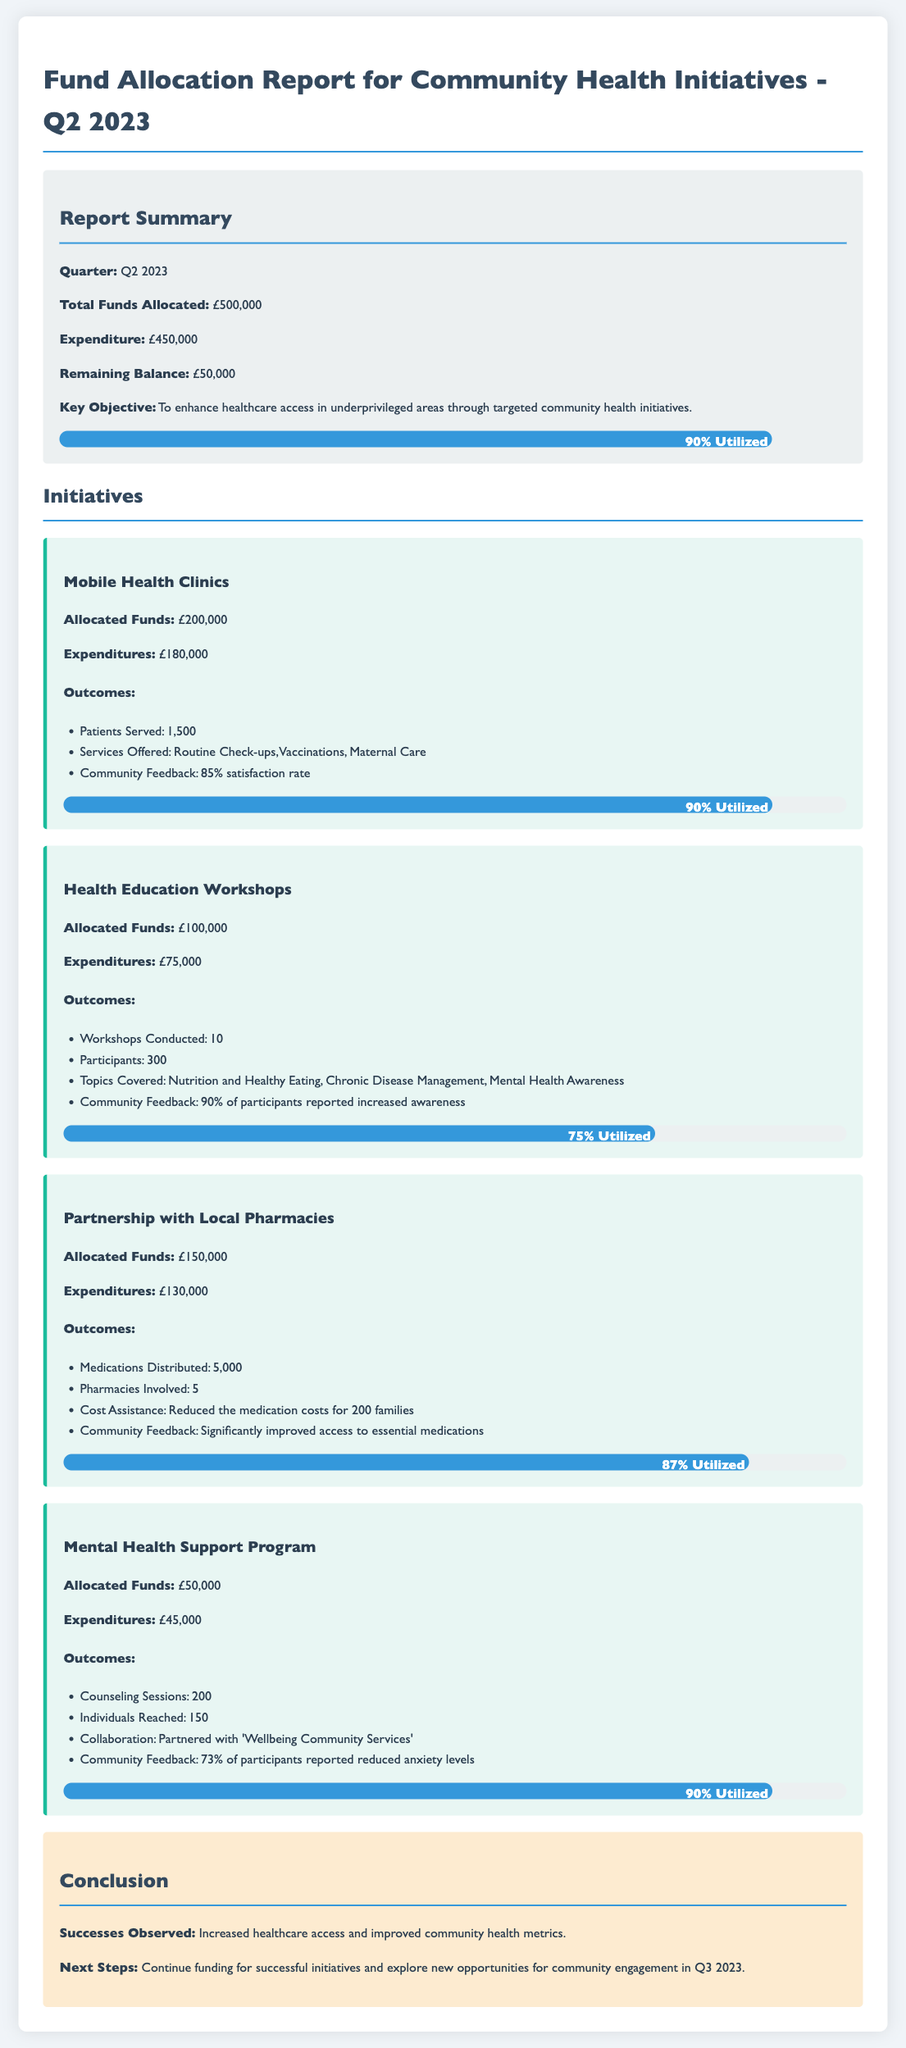what is the total funds allocated? The total funds allocated for community health initiatives in Q2 2023 is stated in the summary section.
Answer: £500,000 how much was spent on Mobile Health Clinics? The expenditures for Mobile Health Clinics can be found in the initiatives section under that specific initiative.
Answer: £180,000 how many patients were served by the Mobile Health Clinics? The number of patients served is detailed in the outcomes section of the Mobile Health Clinics initiative.
Answer: 1,500 what was the participant feedback rate for Health Education Workshops? The community feedback for Health Education Workshops shows the percentage of participants reporting increased awareness, found in the outcomes section.
Answer: 90% how many counseling sessions were conducted in the Mental Health Support Program? The number of counseling sessions is explicitly mentioned in the outcomes of the Mental Health Support Program initiative.
Answer: 200 what is the remaining balance from the total allocation? The remaining balance is calculated by subtracting expenditures from total funds allocated, found in the summary section.
Answer: £50,000 what topics were covered in the Health Education Workshops? The specific topics covered in the Health Education Workshops can be found in the outcomes section of that initiative.
Answer: Nutrition and Healthy Eating, Chronic Disease Management, Mental Health Awareness which initiative had the lowest expenditure? By assessing the expenditures across all initiatives, we can identify which one had the lowest expense.
Answer: Health Education Workshops what is the percentage of funds utilized for the Partnership with Local Pharmacies? The percentage utilized is included in the progress bar section of the Partnership with Local Pharmacies initiative.
Answer: 87% what is the objective of the community health initiatives? The key objective is stated in the summary section of the report.
Answer: To enhance healthcare access in underprivileged areas through targeted community health initiatives 